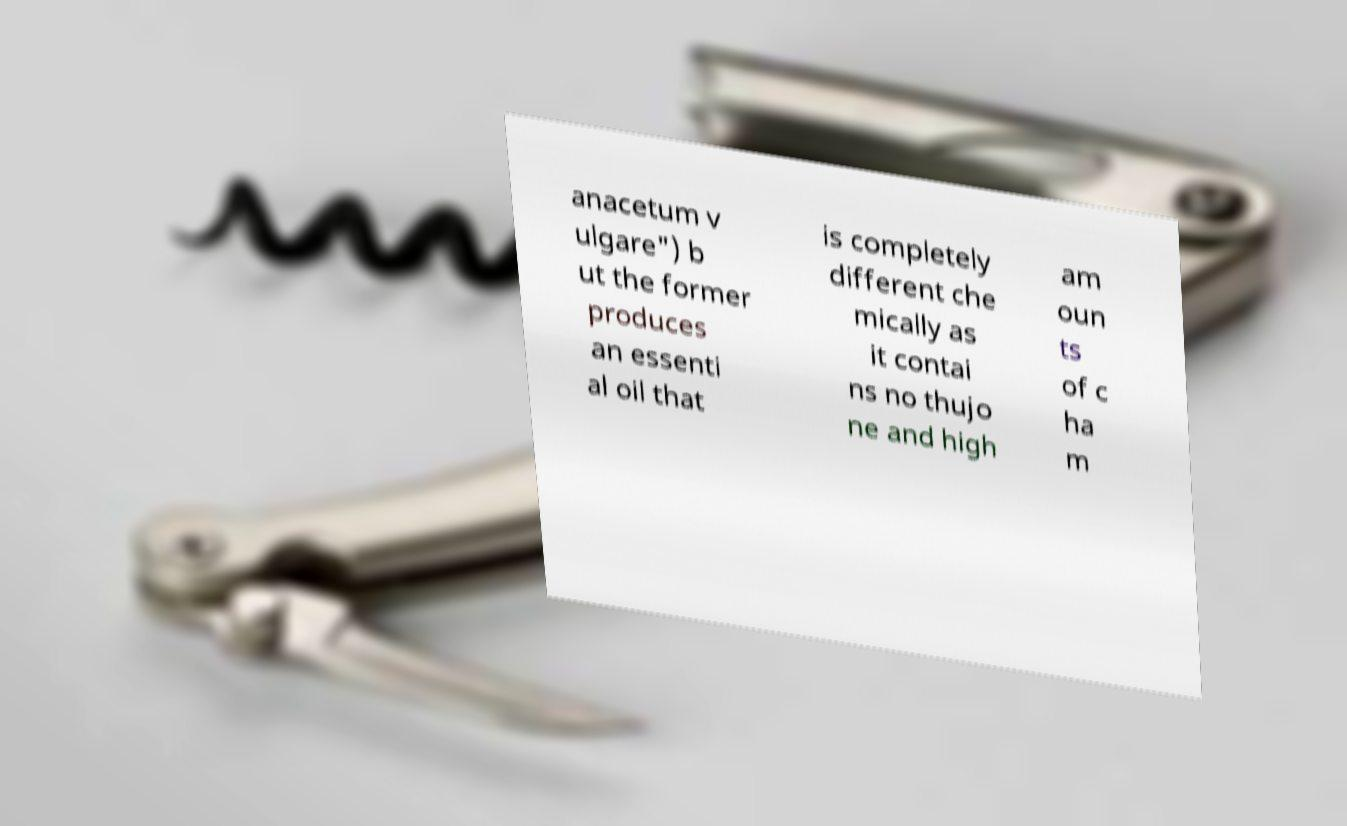What messages or text are displayed in this image? I need them in a readable, typed format. anacetum v ulgare") b ut the former produces an essenti al oil that is completely different che mically as it contai ns no thujo ne and high am oun ts of c ha m 